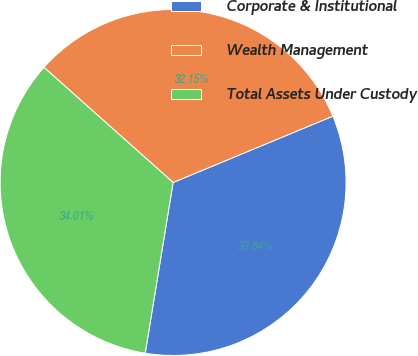Convert chart. <chart><loc_0><loc_0><loc_500><loc_500><pie_chart><fcel>Corporate & Institutional<fcel>Wealth Management<fcel>Total Assets Under Custody<nl><fcel>33.84%<fcel>32.15%<fcel>34.01%<nl></chart> 